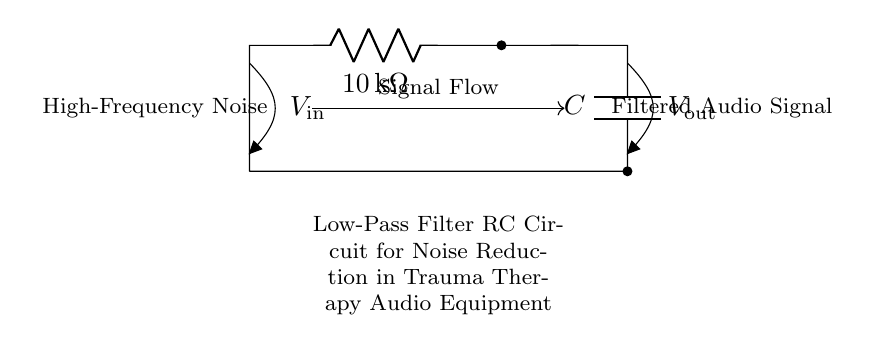What is the resistance value in this circuit? The resistance value in this circuit is indicated next to the resistor symbol, which is labeled as 10 kilohms.
Answer: 10 kilohms What type of filter does this circuit represent? The circuit diagram shows a low-pass filter configuration because it allows low frequencies to pass while attenuating high-frequency components.
Answer: Low-pass filter What is the function of the capacitor in this circuit? The capacitor in this circuit stores and releases electrical energy, smoothing out high-frequency noise and effectively allowing lower frequencies to pass through.
Answer: Noise reduction Where does the input voltage connect in this circuit? The input voltage connects at the top of the circuit, labeled as V-in, indicating that the signal enters the circuit through this point.
Answer: V-in What is the output of this circuit labeled as? The output of this circuit is labeled V-out, indicating the point where the filtered audio signal is taken from the circuit.
Answer: V-out Explain how the circuit reduces noise. This RC circuit reduces noise by using the resistor and capacitor together to form a low-pass filter. The resistor limits the current and, when paired with the capacitor, creates a frequency-dependent voltage divider where high frequencies are shunted to ground by the capacitor, resulting in the output being primarily low-frequency content, thereby reducing noise.
Answer: By shunting high frequencies to ground 